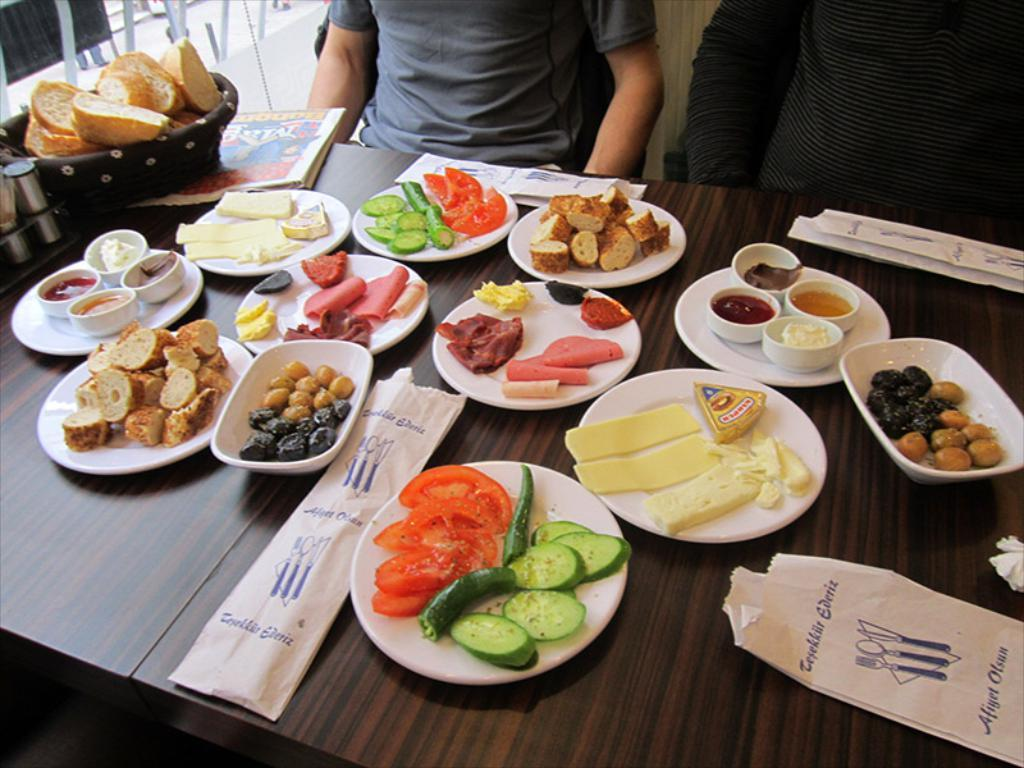What is on the white plate in the image? There are fruit and snacks on a white plate in the image. Where is the plate placed? The plate is placed on a wooden table top. Can you describe the background of the image? There is a man sitting on a chair in the background. What type of crate is being used to weigh the fruit and snacks in the image? There is no crate present in the image, and the fruit and snacks are not being weighed. 